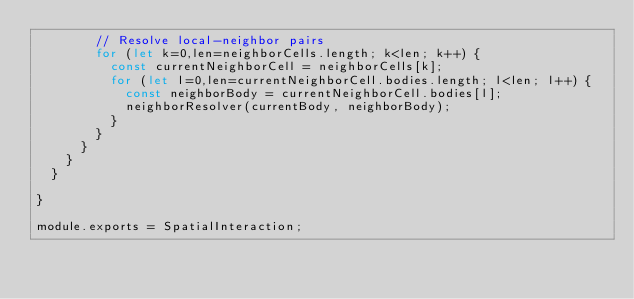Convert code to text. <code><loc_0><loc_0><loc_500><loc_500><_JavaScript_>        // Resolve local-neighbor pairs
        for (let k=0,len=neighborCells.length; k<len; k++) {
          const currentNeighborCell = neighborCells[k];
          for (let l=0,len=currentNeighborCell.bodies.length; l<len; l++) {
            const neighborBody = currentNeighborCell.bodies[l];
            neighborResolver(currentBody, neighborBody);
          }
        }
      }
    }
	}

}

module.exports = SpatialInteraction;
</code> 